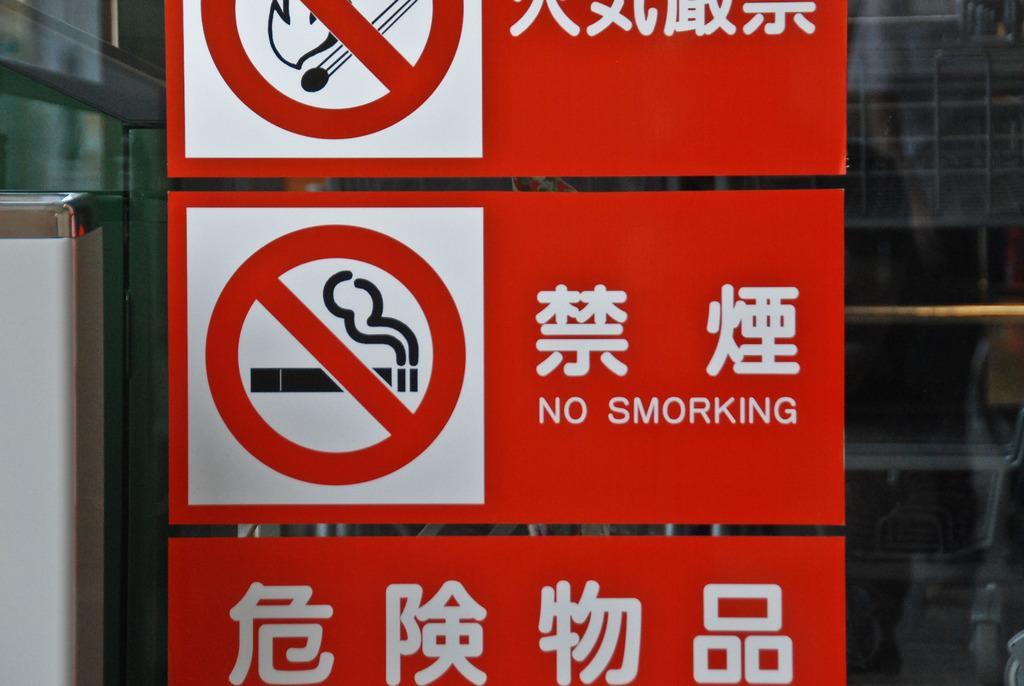How would you summarize this image in a sentence or two? In the picture I can see red color caution boards on which we can see some text and some images are pasted on the glass doors. 